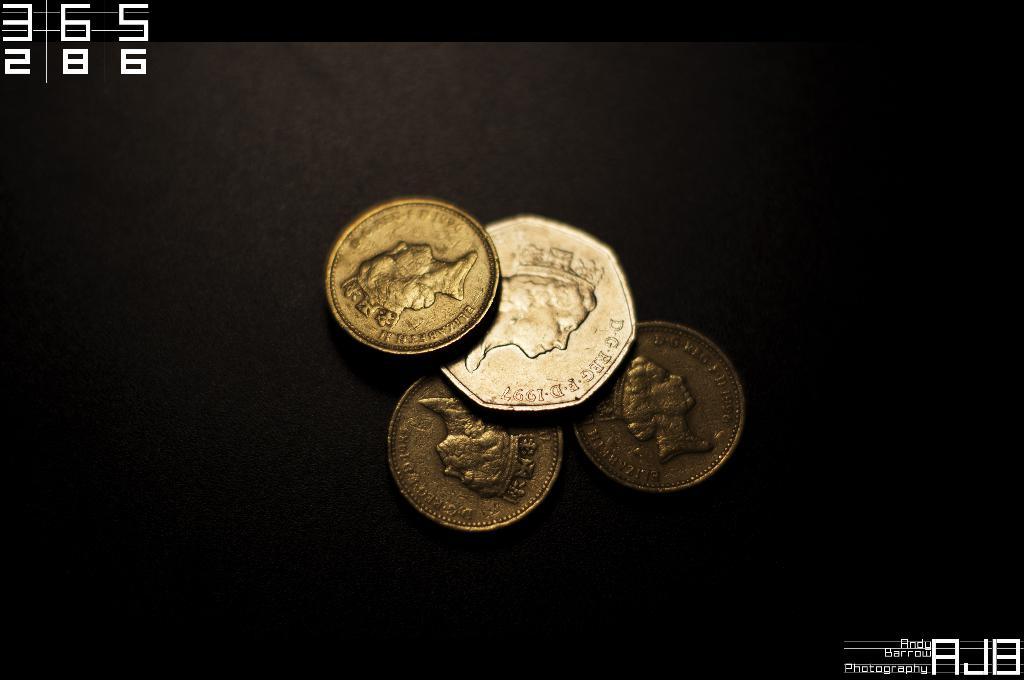What are the top three numbers?
Ensure brevity in your answer.  365. 